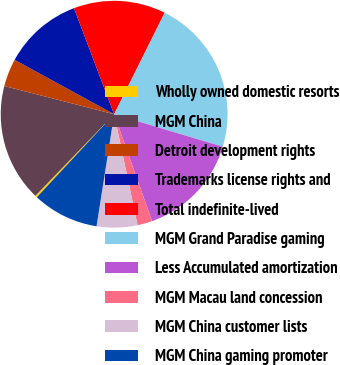<chart> <loc_0><loc_0><loc_500><loc_500><pie_chart><fcel>Wholly owned domestic resorts<fcel>MGM China<fcel>Detroit development rights<fcel>Trademarks license rights and<fcel>Total indefinite-lived<fcel>MGM Grand Paradise gaming<fcel>Less Accumulated amortization<fcel>MGM Macau land concession<fcel>MGM China customer lists<fcel>MGM China gaming promoter<nl><fcel>0.29%<fcel>16.78%<fcel>3.96%<fcel>11.28%<fcel>13.11%<fcel>22.27%<fcel>14.95%<fcel>2.12%<fcel>5.79%<fcel>9.45%<nl></chart> 